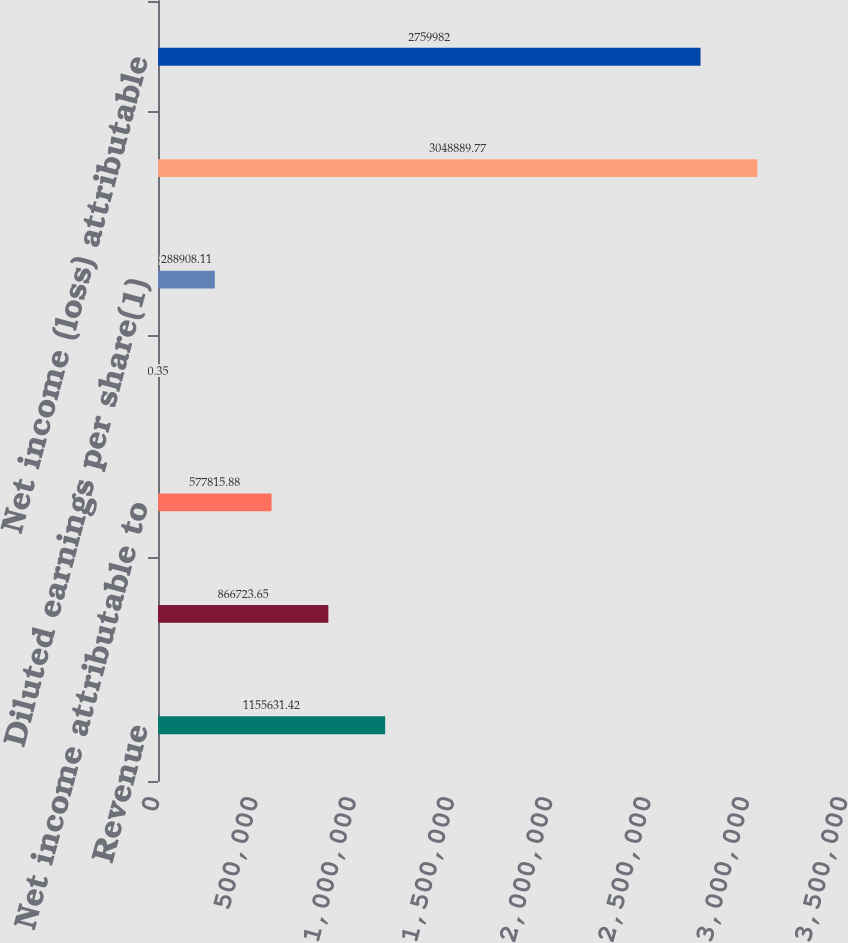Convert chart to OTSL. <chart><loc_0><loc_0><loc_500><loc_500><bar_chart><fcel>Revenue<fcel>Operating income<fcel>Net income attributable to<fcel>Basic earnings per share(1)<fcel>Diluted earnings per share(1)<fcel>Operating income (loss)(2)<fcel>Net income (loss) attributable<nl><fcel>1.15563e+06<fcel>866724<fcel>577816<fcel>0.35<fcel>288908<fcel>3.04889e+06<fcel>2.75998e+06<nl></chart> 